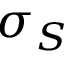Convert formula to latex. <formula><loc_0><loc_0><loc_500><loc_500>\sigma _ { S }</formula> 